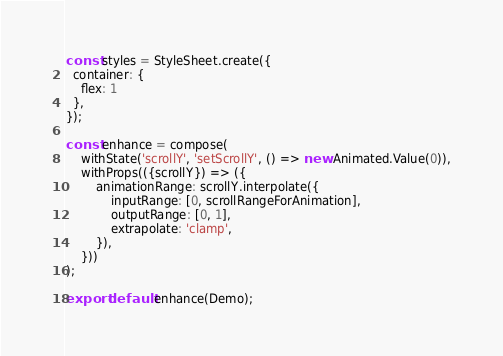<code> <loc_0><loc_0><loc_500><loc_500><_JavaScript_>
const styles = StyleSheet.create({
  container: {
    flex: 1
  },
});

const enhance = compose(
    withState('scrollY', 'setScrollY', () => new Animated.Value(0)),
    withProps(({scrollY}) => ({
        animationRange: scrollY.interpolate({
            inputRange: [0, scrollRangeForAnimation],
            outputRange: [0, 1],
            extrapolate: 'clamp',
        }),
    }))
);

export default enhance(Demo);
</code> 